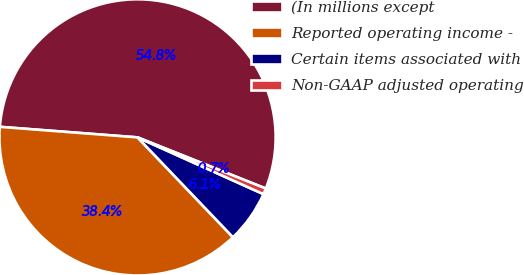<chart> <loc_0><loc_0><loc_500><loc_500><pie_chart><fcel>(In millions except<fcel>Reported operating income -<fcel>Certain items associated with<fcel>Non-GAAP adjusted operating<nl><fcel>54.82%<fcel>38.36%<fcel>6.12%<fcel>0.7%<nl></chart> 